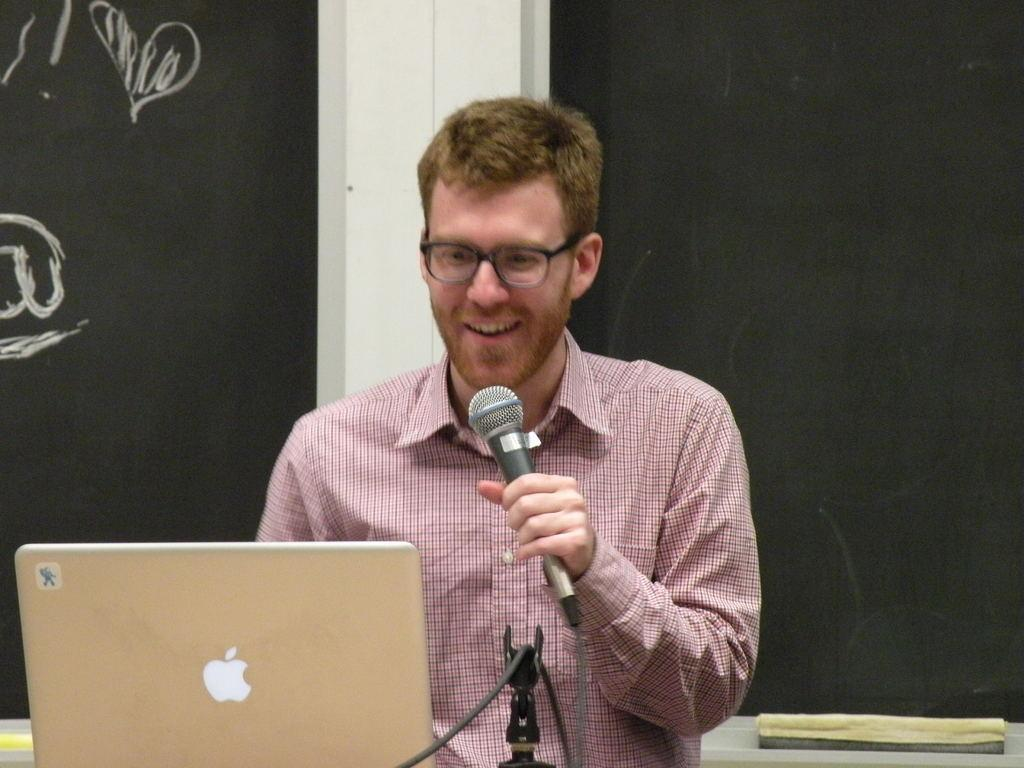Who is present in the image? There is a man in the image. What is the man holding in the image? The man is holding a microphone. What is the man looking at in the image? The man is looking at a laptop. What can be seen behind the man in the image? The background of the image is a blackboard. Can you see any ocean waves in the image? There is no ocean or waves present in the image; the background is a blackboard. 